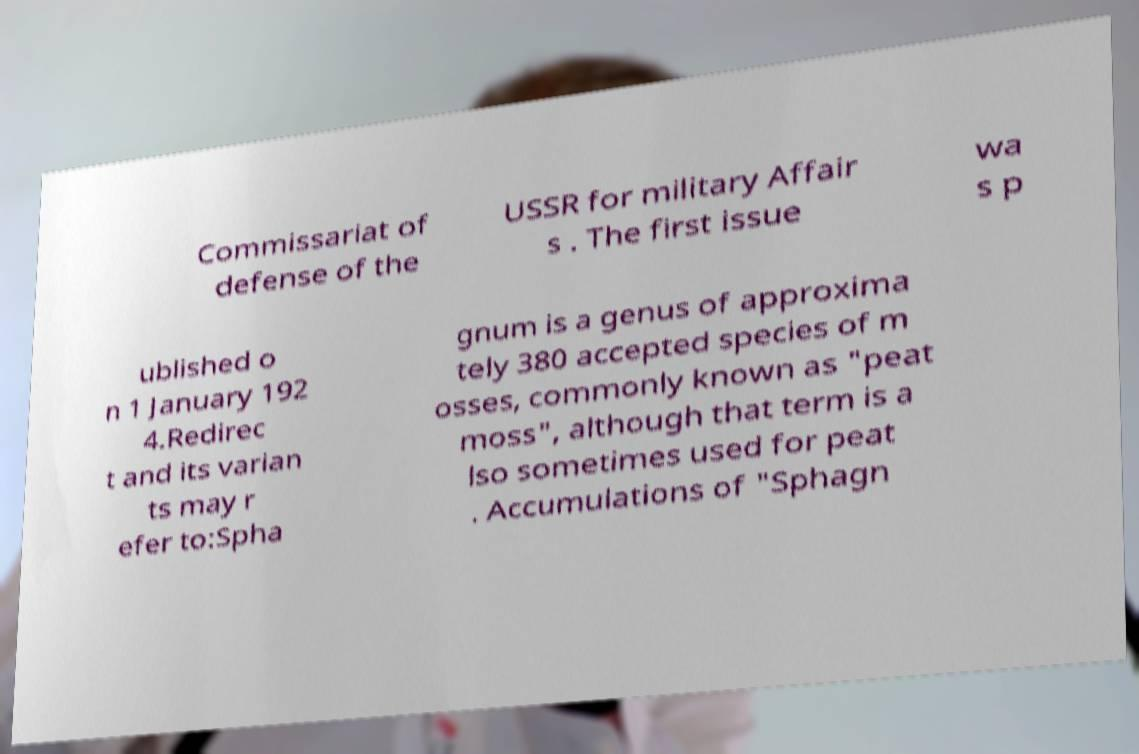Can you read and provide the text displayed in the image?This photo seems to have some interesting text. Can you extract and type it out for me? Commissariat of defense of the USSR for military Affair s . The first issue wa s p ublished o n 1 January 192 4.Redirec t and its varian ts may r efer to:Spha gnum is a genus of approxima tely 380 accepted species of m osses, commonly known as "peat moss", although that term is a lso sometimes used for peat . Accumulations of "Sphagn 